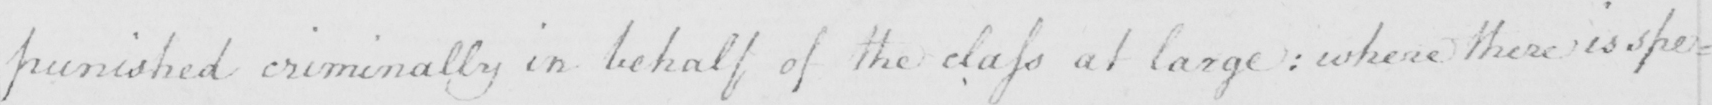Can you tell me what this handwritten text says? punished criminally in behalf of the class at large :  where there is spe= 